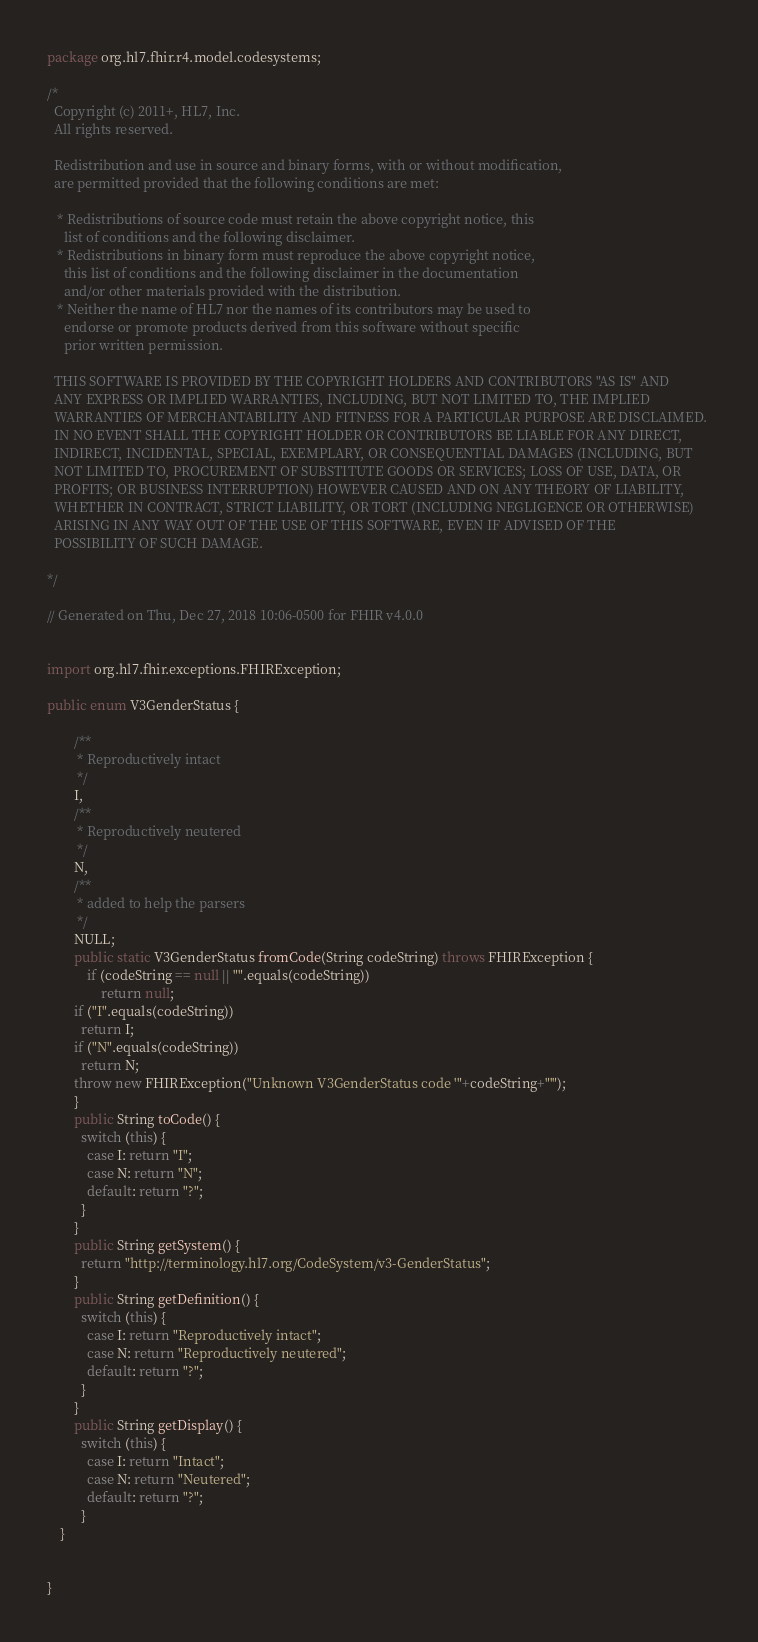Convert code to text. <code><loc_0><loc_0><loc_500><loc_500><_Java_>package org.hl7.fhir.r4.model.codesystems;

/*
  Copyright (c) 2011+, HL7, Inc.
  All rights reserved.
  
  Redistribution and use in source and binary forms, with or without modification, 
  are permitted provided that the following conditions are met:
  
   * Redistributions of source code must retain the above copyright notice, this 
     list of conditions and the following disclaimer.
   * Redistributions in binary form must reproduce the above copyright notice, 
     this list of conditions and the following disclaimer in the documentation 
     and/or other materials provided with the distribution.
   * Neither the name of HL7 nor the names of its contributors may be used to 
     endorse or promote products derived from this software without specific 
     prior written permission.
  
  THIS SOFTWARE IS PROVIDED BY THE COPYRIGHT HOLDERS AND CONTRIBUTORS "AS IS" AND 
  ANY EXPRESS OR IMPLIED WARRANTIES, INCLUDING, BUT NOT LIMITED TO, THE IMPLIED 
  WARRANTIES OF MERCHANTABILITY AND FITNESS FOR A PARTICULAR PURPOSE ARE DISCLAIMED. 
  IN NO EVENT SHALL THE COPYRIGHT HOLDER OR CONTRIBUTORS BE LIABLE FOR ANY DIRECT, 
  INDIRECT, INCIDENTAL, SPECIAL, EXEMPLARY, OR CONSEQUENTIAL DAMAGES (INCLUDING, BUT 
  NOT LIMITED TO, PROCUREMENT OF SUBSTITUTE GOODS OR SERVICES; LOSS OF USE, DATA, OR 
  PROFITS; OR BUSINESS INTERRUPTION) HOWEVER CAUSED AND ON ANY THEORY OF LIABILITY, 
  WHETHER IN CONTRACT, STRICT LIABILITY, OR TORT (INCLUDING NEGLIGENCE OR OTHERWISE) 
  ARISING IN ANY WAY OUT OF THE USE OF THIS SOFTWARE, EVEN IF ADVISED OF THE 
  POSSIBILITY OF SUCH DAMAGE.
  
*/

// Generated on Thu, Dec 27, 2018 10:06-0500 for FHIR v4.0.0


import org.hl7.fhir.exceptions.FHIRException;

public enum V3GenderStatus {

        /**
         * Reproductively intact
         */
        I, 
        /**
         * Reproductively neutered
         */
        N, 
        /**
         * added to help the parsers
         */
        NULL;
        public static V3GenderStatus fromCode(String codeString) throws FHIRException {
            if (codeString == null || "".equals(codeString))
                return null;
        if ("I".equals(codeString))
          return I;
        if ("N".equals(codeString))
          return N;
        throw new FHIRException("Unknown V3GenderStatus code '"+codeString+"'");
        }
        public String toCode() {
          switch (this) {
            case I: return "I";
            case N: return "N";
            default: return "?";
          }
        }
        public String getSystem() {
          return "http://terminology.hl7.org/CodeSystem/v3-GenderStatus";
        }
        public String getDefinition() {
          switch (this) {
            case I: return "Reproductively intact";
            case N: return "Reproductively neutered";
            default: return "?";
          }
        }
        public String getDisplay() {
          switch (this) {
            case I: return "Intact";
            case N: return "Neutered";
            default: return "?";
          }
    }


}

</code> 